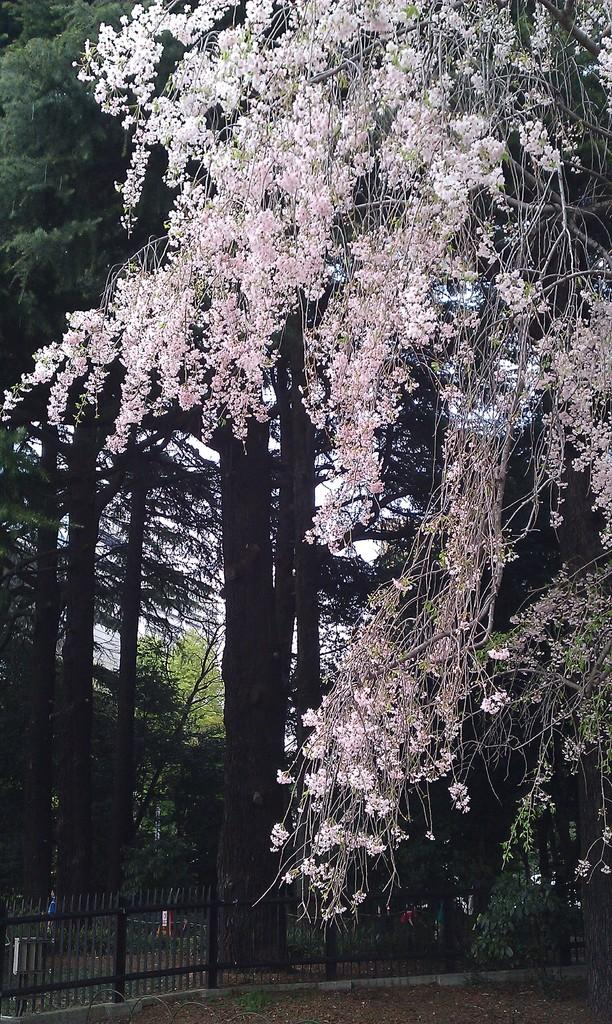What type of vegetation can be seen in the image? There are trees in the image. What is the purpose of the structure visible in the image? The image contains a fence, which is typically used to enclose an area or mark a boundary. What is visible at the bottom of the image? The ground is visible at the bottom of the image. Can you see any veins on the trees in the image? There are no veins visible on the trees in the image, as veins are not a visible part of trees. What type of face can be seen in the image? There are no faces present in the image; it features trees and a fence. 